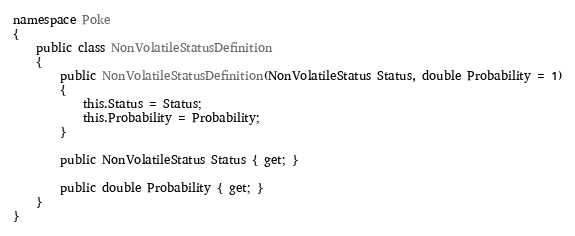<code> <loc_0><loc_0><loc_500><loc_500><_C#_>namespace Poke
{
    public class NonVolatileStatusDefinition
    {
        public NonVolatileStatusDefinition(NonVolatileStatus Status, double Probability = 1)
        {
            this.Status = Status;
            this.Probability = Probability;
        }

        public NonVolatileStatus Status { get; }

        public double Probability { get; }
    }
}</code> 